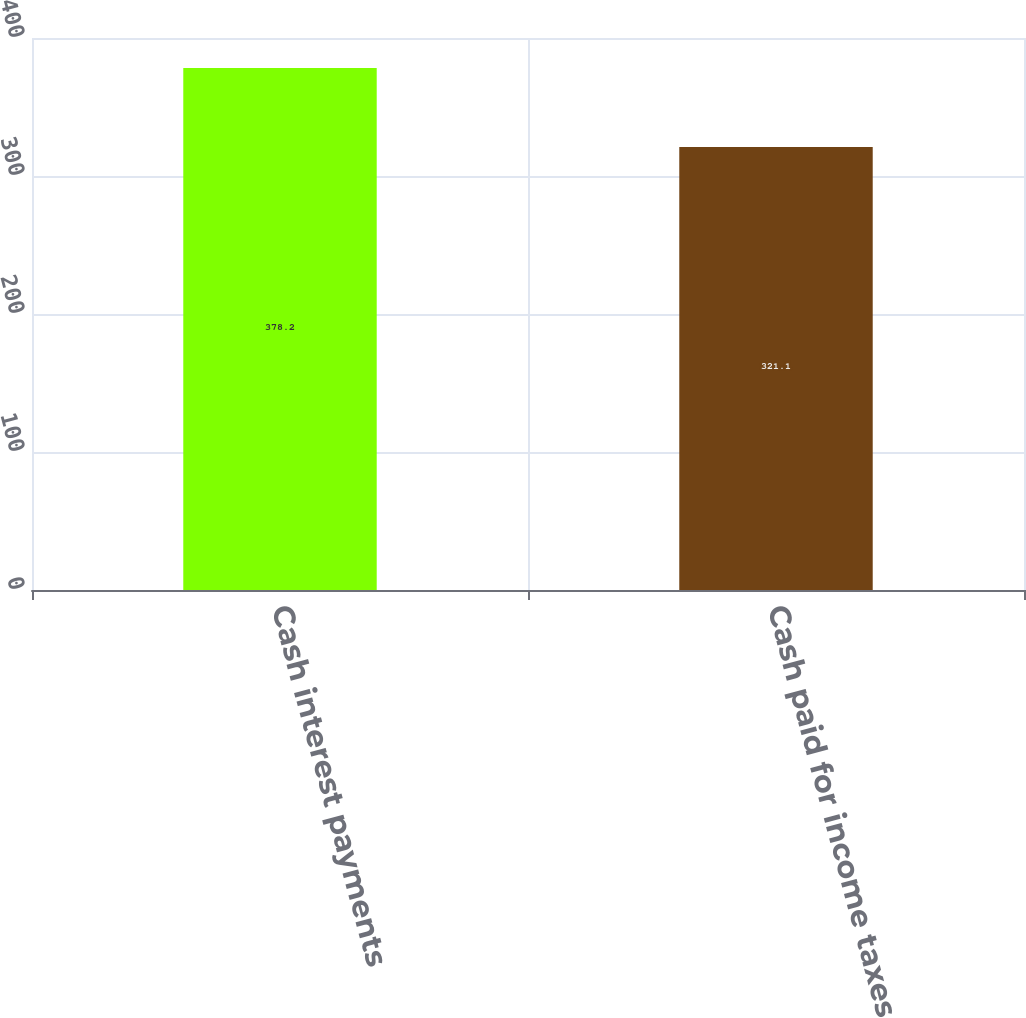<chart> <loc_0><loc_0><loc_500><loc_500><bar_chart><fcel>Cash interest payments<fcel>Cash paid for income taxes<nl><fcel>378.2<fcel>321.1<nl></chart> 